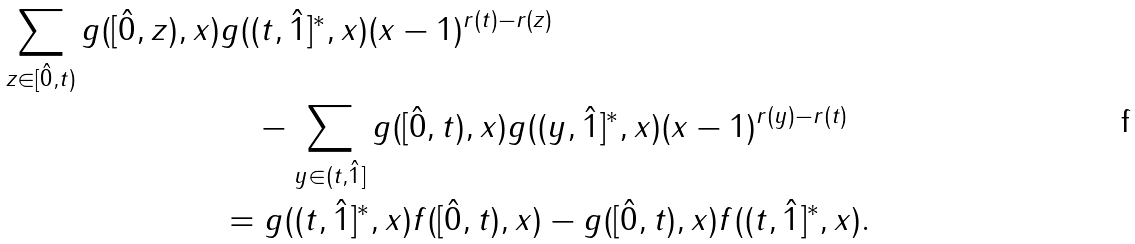<formula> <loc_0><loc_0><loc_500><loc_500>\sum _ { z \in [ \hat { 0 } , t ) } g ( [ \hat { 0 } , z ) , x ) & g ( ( t , \hat { 1 } ] ^ { * } , x ) ( x - 1 ) ^ { r ( t ) - r ( z ) } \\ & \quad - \sum _ { y \in ( t , \hat { 1 } ] } g ( [ \hat { 0 } , t ) , x ) g ( ( y , \hat { 1 } ] ^ { * } , x ) ( x - 1 ) ^ { r ( y ) - r ( t ) } \\ & = g ( ( t , \hat { 1 } ] ^ { * } , x ) f ( [ \hat { 0 } , t ) , x ) - g ( [ \hat { 0 } , t ) , x ) f ( ( t , \hat { 1 } ] ^ { * } , x ) .</formula> 